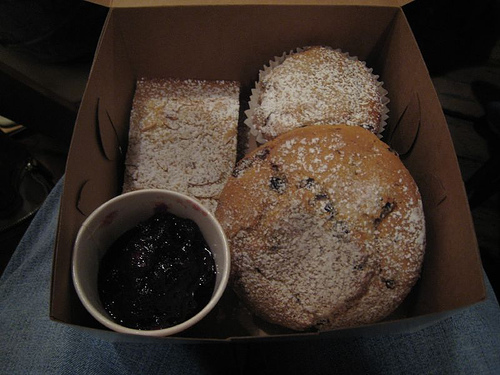<image>
Is the muffin on the cupcake? Yes. Looking at the image, I can see the muffin is positioned on top of the cupcake, with the cupcake providing support. 